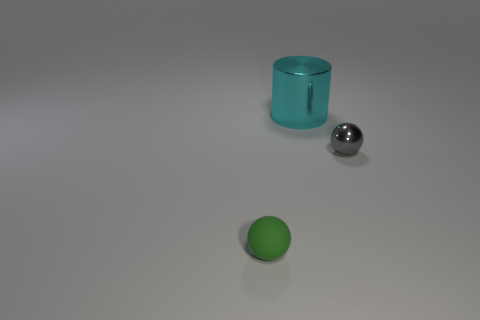Add 2 big objects. How many objects exist? 5 Subtract all gray spheres. How many spheres are left? 1 Subtract all cylinders. How many objects are left? 2 Add 3 tiny shiny balls. How many tiny shiny balls are left? 4 Add 2 green rubber spheres. How many green rubber spheres exist? 3 Subtract 1 green spheres. How many objects are left? 2 Subtract 2 spheres. How many spheres are left? 0 Subtract all gray balls. Subtract all blue cylinders. How many balls are left? 1 Subtract all green cylinders. How many brown balls are left? 0 Subtract all small objects. Subtract all green balls. How many objects are left? 0 